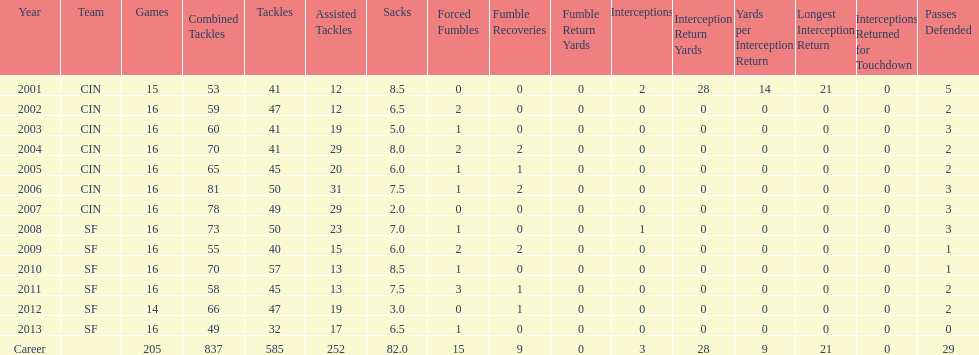In which years did he play less than 16 games? 2. 